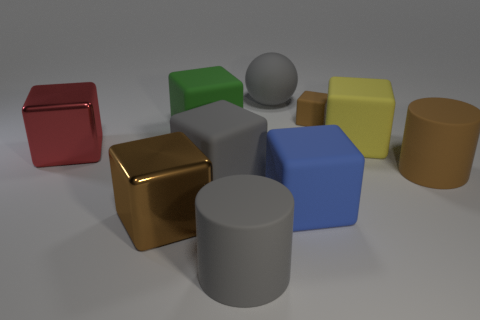Subtract all large matte blocks. How many blocks are left? 3 Subtract all gray cylinders. How many cylinders are left? 1 Subtract 6 blocks. How many blocks are left? 1 Add 5 big red shiny things. How many big red shiny things are left? 6 Add 2 tiny cyan matte objects. How many tiny cyan matte objects exist? 2 Subtract 1 red blocks. How many objects are left? 9 Subtract all balls. How many objects are left? 9 Subtract all green cylinders. Subtract all cyan spheres. How many cylinders are left? 2 Subtract all cyan blocks. How many blue balls are left? 0 Subtract all large yellow cubes. Subtract all large yellow matte things. How many objects are left? 8 